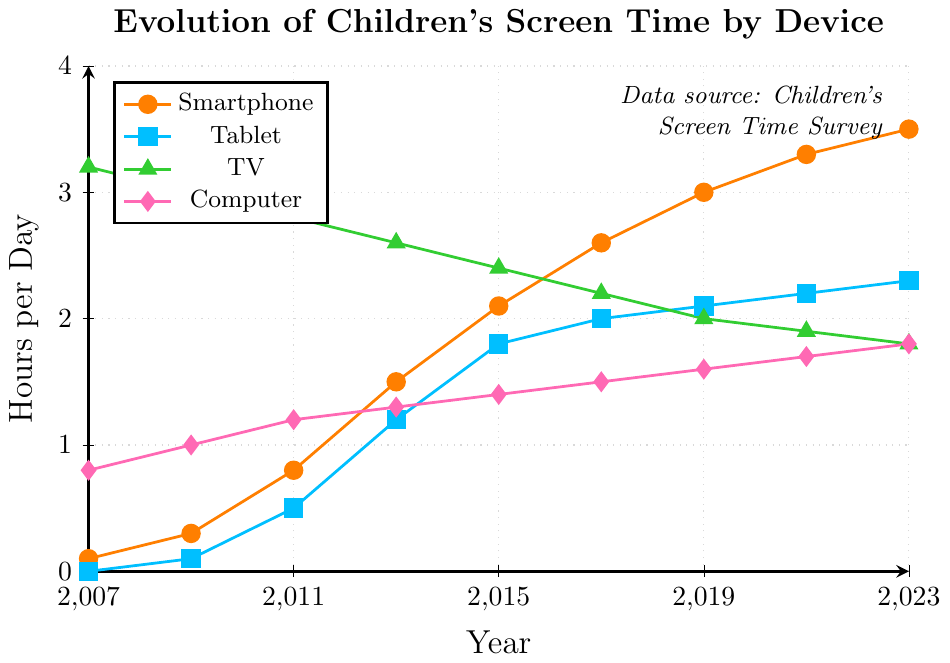What year did children's screen time on smartphones surpass that of TV? To determine the year when smartphone screen time surpassed TV screen time, look at the two lines representing smartphones and TV. The smartphone line surpasses the TV line between the years 2015 and 2017. By comparing the exact values, smartphone time exceeds TV in 2017.
Answer: 2017 Which device showed the greatest increase in screen time from 2007 to 2023? Find the screen time for all devices in 2007 and 2023. Subtract the 2007 values from the 2023 values for each device. Compute the increases: Smartphone (3.5 - 0.1 = 3.4), Tablet (2.3 - 0 = 2.3), TV (1.8 - 3.2 = -1.4), Computer (1.8 - 0.8 = 1.0). The smartphone shows the greatest increase.
Answer: Smartphone What's the average screen time for tablets over the period from 2007 to 2023? Sum the screen time values for tablets (0 + 0.1 + 0.5 + 1.2 + 1.8 + 2.0 + 2.1 + 2.2 + 2.3) and divide by the number of years (9). The sum is 12.2, and the average is 12.2/9.
Answer: 1.36 In which year was the screen time for computers equal to 1.4 hours per day? Locate the year on the plot where the line for computers intersects the 1.4 hours per day mark. This occurs in the year 2015.
Answer: 2015 Compare the screen time trends for TV and Computer from 2007 to 2023. Which one shows a decreasing trend? Look at the lines for TV and Computer. The TV line shows a decreasing trend from 3.2 hours in 2007 to 1.8 hours in 2023. The computer line shows a steady increase from 0.8 hours to 1.8 hours. The decreasing trend is seen in TV.
Answer: TV What is the approximate difference in screen time between smartphones and tablets in 2023? Find the screen time values for both smartphones (3.5 hours) and tablets (2.3 hours) in 2023. Subtract the tablet value from the smartphone value (3.5 - 2.3).
Answer: 1.2 hours Summarize the screen time for TV and smartphones in 2015. Which one was higher and by how much? Look at the screen time for TV (2.4 hours) and smartphones (2.1 hours) in 2015. TV had higher screen time. The difference is 2.4 - 2.1.
Answer: 0.3 hours (TV higher) What's the slope of the increase in smartphone screen time from 2007 to 2023? Calculate the change in screen time from 2007 to 2023 for smartphones (3.5 - 0.1). Divide by the number of years (2023 - 2007). The slope is (3.5 - 0.1)/16.
Answer: 0.2125 hours per year During which period (year range) did tablet usage show the most significant growth? Evaluate the increase in tablet usage for each period: 2007-2009, 2009-2011, etc. The most significant growth is from 2011 (0.5) to 2013 (1.2), an increase of 0.7 hours. Thus, the period is 2011 to 2013.
Answer: 2011-2013 